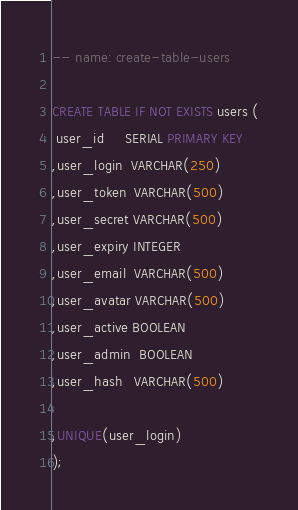Convert code to text. <code><loc_0><loc_0><loc_500><loc_500><_SQL_>-- name: create-table-users

CREATE TABLE IF NOT EXISTS users (
 user_id     SERIAL PRIMARY KEY
,user_login  VARCHAR(250)
,user_token  VARCHAR(500)
,user_secret VARCHAR(500)
,user_expiry INTEGER
,user_email  VARCHAR(500)
,user_avatar VARCHAR(500)
,user_active BOOLEAN
,user_admin  BOOLEAN
,user_hash   VARCHAR(500)

,UNIQUE(user_login)
);
</code> 